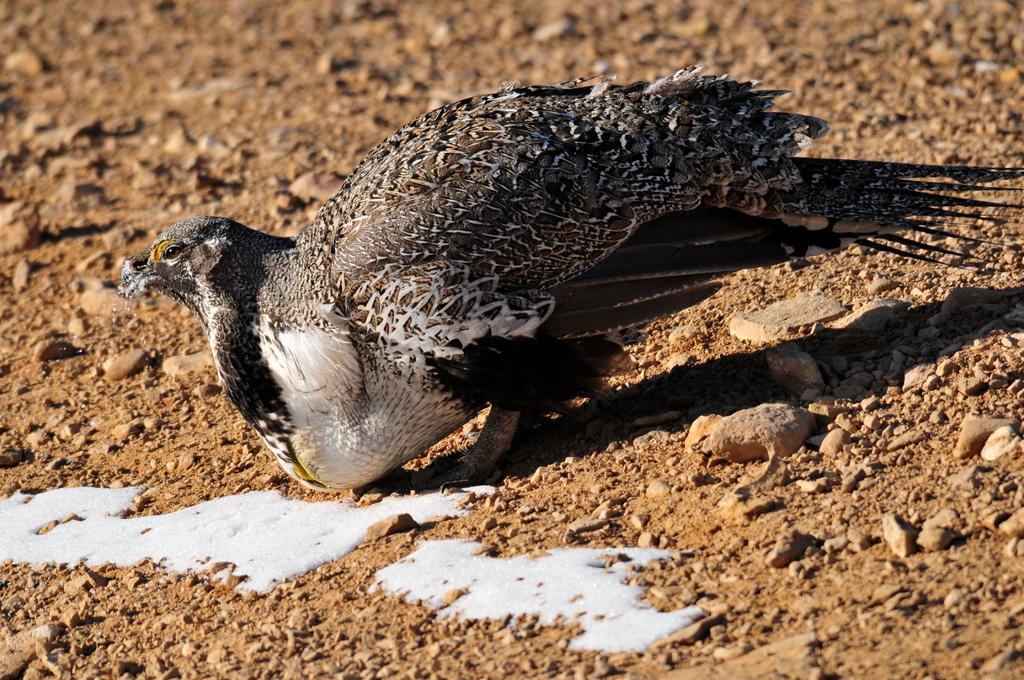Please provide a concise description of this image. In this image we can see a bird, small stones and white color liquid on the ground. 